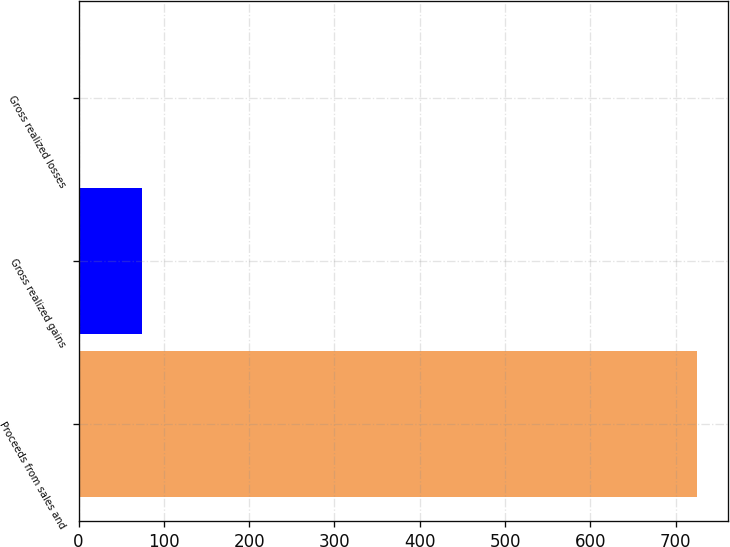Convert chart. <chart><loc_0><loc_0><loc_500><loc_500><bar_chart><fcel>Proceeds from sales and<fcel>Gross realized gains<fcel>Gross realized losses<nl><fcel>725<fcel>74.57<fcel>2.3<nl></chart> 